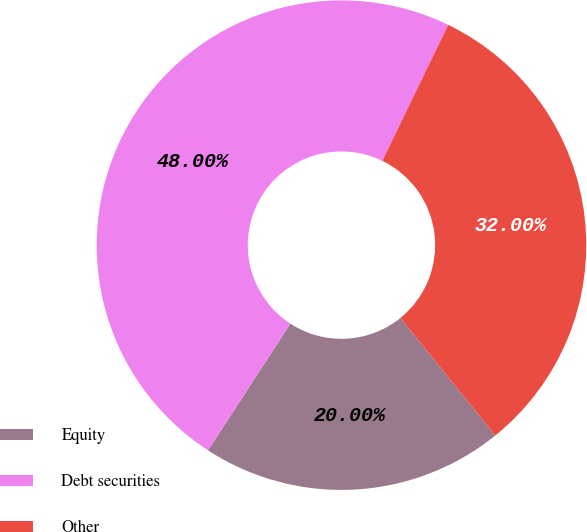<chart> <loc_0><loc_0><loc_500><loc_500><pie_chart><fcel>Equity<fcel>Debt securities<fcel>Other<nl><fcel>20.0%<fcel>48.0%<fcel>32.0%<nl></chart> 